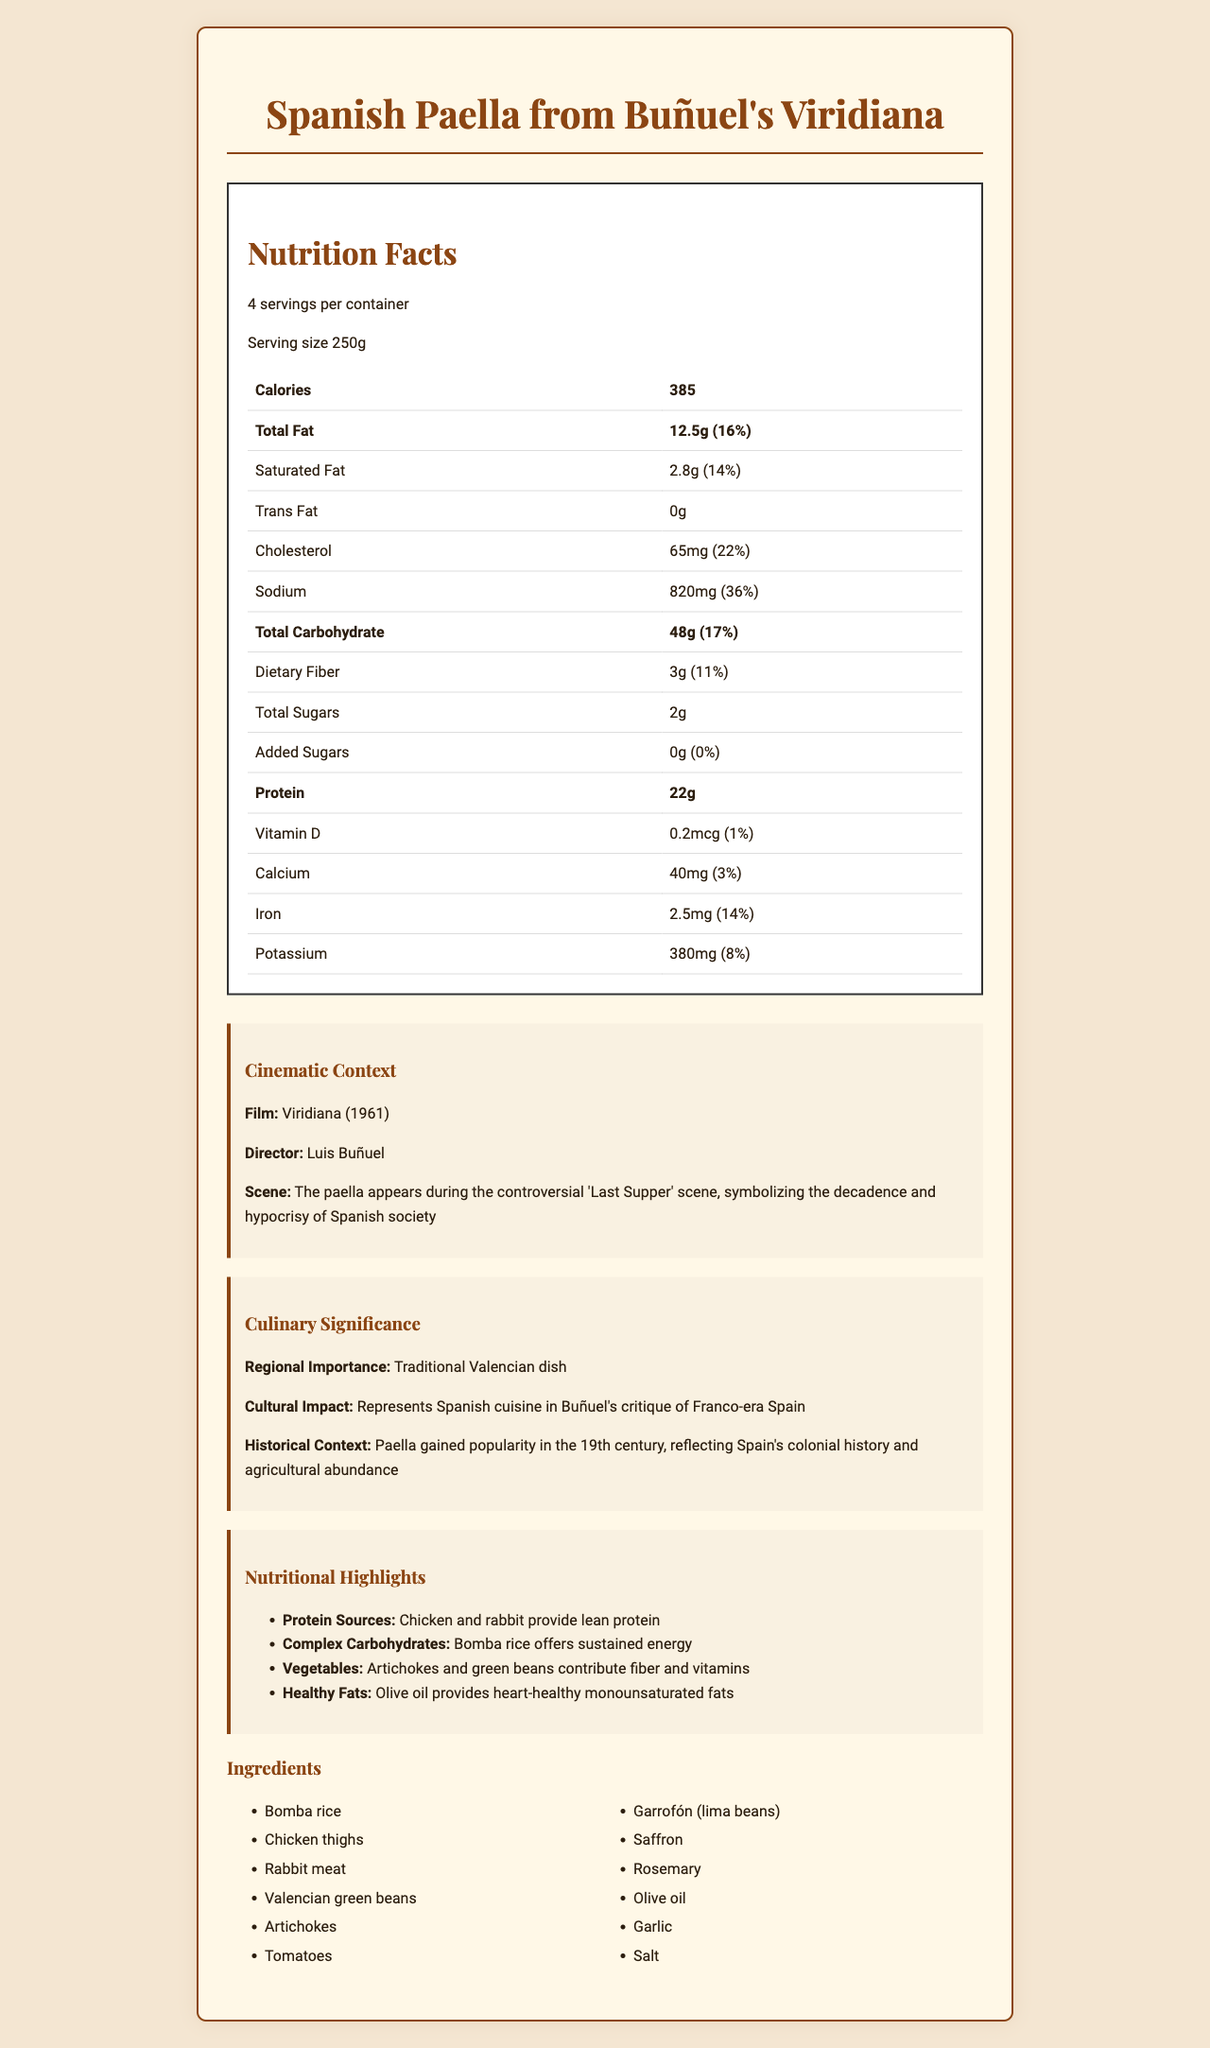What is the serving size for the Spanish Paella? The document lists "serving size" as 250g under the nutrition facts section.
Answer: 250g How many servings per container are there? The document specifies "servings per container" as 4.
Answer: 4 How many calories are in one serving of the Spanish Paella? The calories count per serving is mentioned as 385.
Answer: 385 What amount of dietary fiber does one serving contain? The document states that there are 3g of dietary fiber per serving.
Answer: 3g What percentage of the daily value of sodium does one serving provide? The sodium amount and its daily value percentage (820mg, 36%) are listed in the nutrition facts.
Answer: 36% Which of the following ingredients is not included in the paella? A. Shrimp B. Chicken thighs C. Artichokes D. Bomba rice The ingredient list includes "Chicken thighs," "Artichokes," and "Bomba rice," but not "Shrimp."
Answer: A. Shrimp Which year was Buñuel's "Viridiana" released? A. 1957 B. 1961 C. 1965 D. 1970 The "Cinematic Context" section mentions the release year as 1961.
Answer: B. 1961 Is there any added sugar in the Spanish Paella? The document lists the amount of added sugars as 0g.
Answer: No Summarize the main idea of the document. The document details the paella's serving size, nutrients, and daily value percentages, as well as explaining its importance in the film and Spanish culture, and lists the ingredients used.
Answer: The document provides a comprehensive profile of the Spanish Paella featured in Buñuel's "Viridiana," including its nutritional facts, cinematic and cultural significance, and the list of ingredients. What is the significance of the paella in Buñuel's "Viridiana"? The document states that the paella appears during the controversial 'Last Supper' scene and symbolizes the decadence and hypocrisy of Spanish society.
Answer: It symbolizes the decadence and hypocrisy of Spanish society. How much protein is in a single serving? The nutrition facts list the amount of protein per serving as 22g.
Answer: 22g What amount of calcium does each serving of the paella provide? The document mentions that there are 40mg of calcium in one serving.
Answer: 40mg What is one of the protein sources in the Spanish Paella? The "Nutritional Highlights" section lists chicken as a source of lean protein.
Answer: Chicken Does the document provide information about the cooking method of the paella? There is no information about the cooking method in the provided document.
Answer: No How does the paella contribute to sustained energy? The "Nutritional Highlights" section indicates that Bomba rice provides complex carbohydrates that offer sustained energy.
Answer: Through Bomba rice, which offers complex carbohydrates. How much iron does the paella contain per serving? The nutrition facts specify that each serving contains 2.5mg of iron.
Answer: 2.5mg 